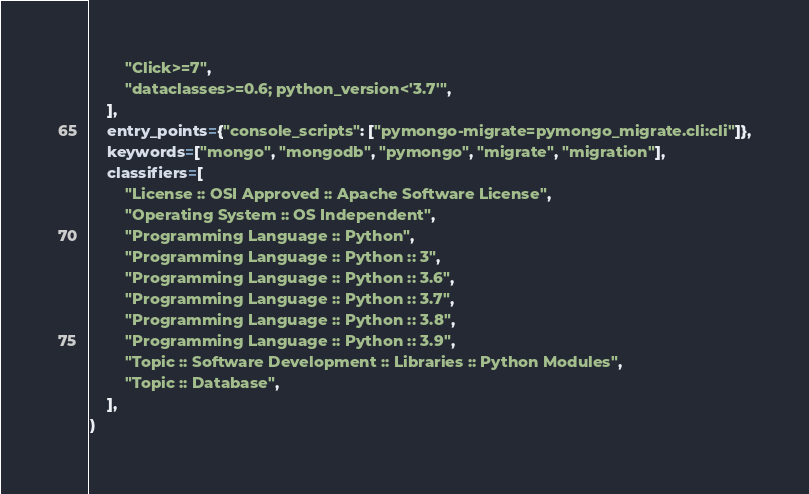Convert code to text. <code><loc_0><loc_0><loc_500><loc_500><_Python_>        "Click>=7",
        "dataclasses>=0.6; python_version<'3.7'",
    ],
    entry_points={"console_scripts": ["pymongo-migrate=pymongo_migrate.cli:cli"]},
    keywords=["mongo", "mongodb", "pymongo", "migrate", "migration"],
    classifiers=[
        "License :: OSI Approved :: Apache Software License",
        "Operating System :: OS Independent",
        "Programming Language :: Python",
        "Programming Language :: Python :: 3",
        "Programming Language :: Python :: 3.6",
        "Programming Language :: Python :: 3.7",
        "Programming Language :: Python :: 3.8",
        "Programming Language :: Python :: 3.9",
        "Topic :: Software Development :: Libraries :: Python Modules",
        "Topic :: Database",
    ],
)
</code> 